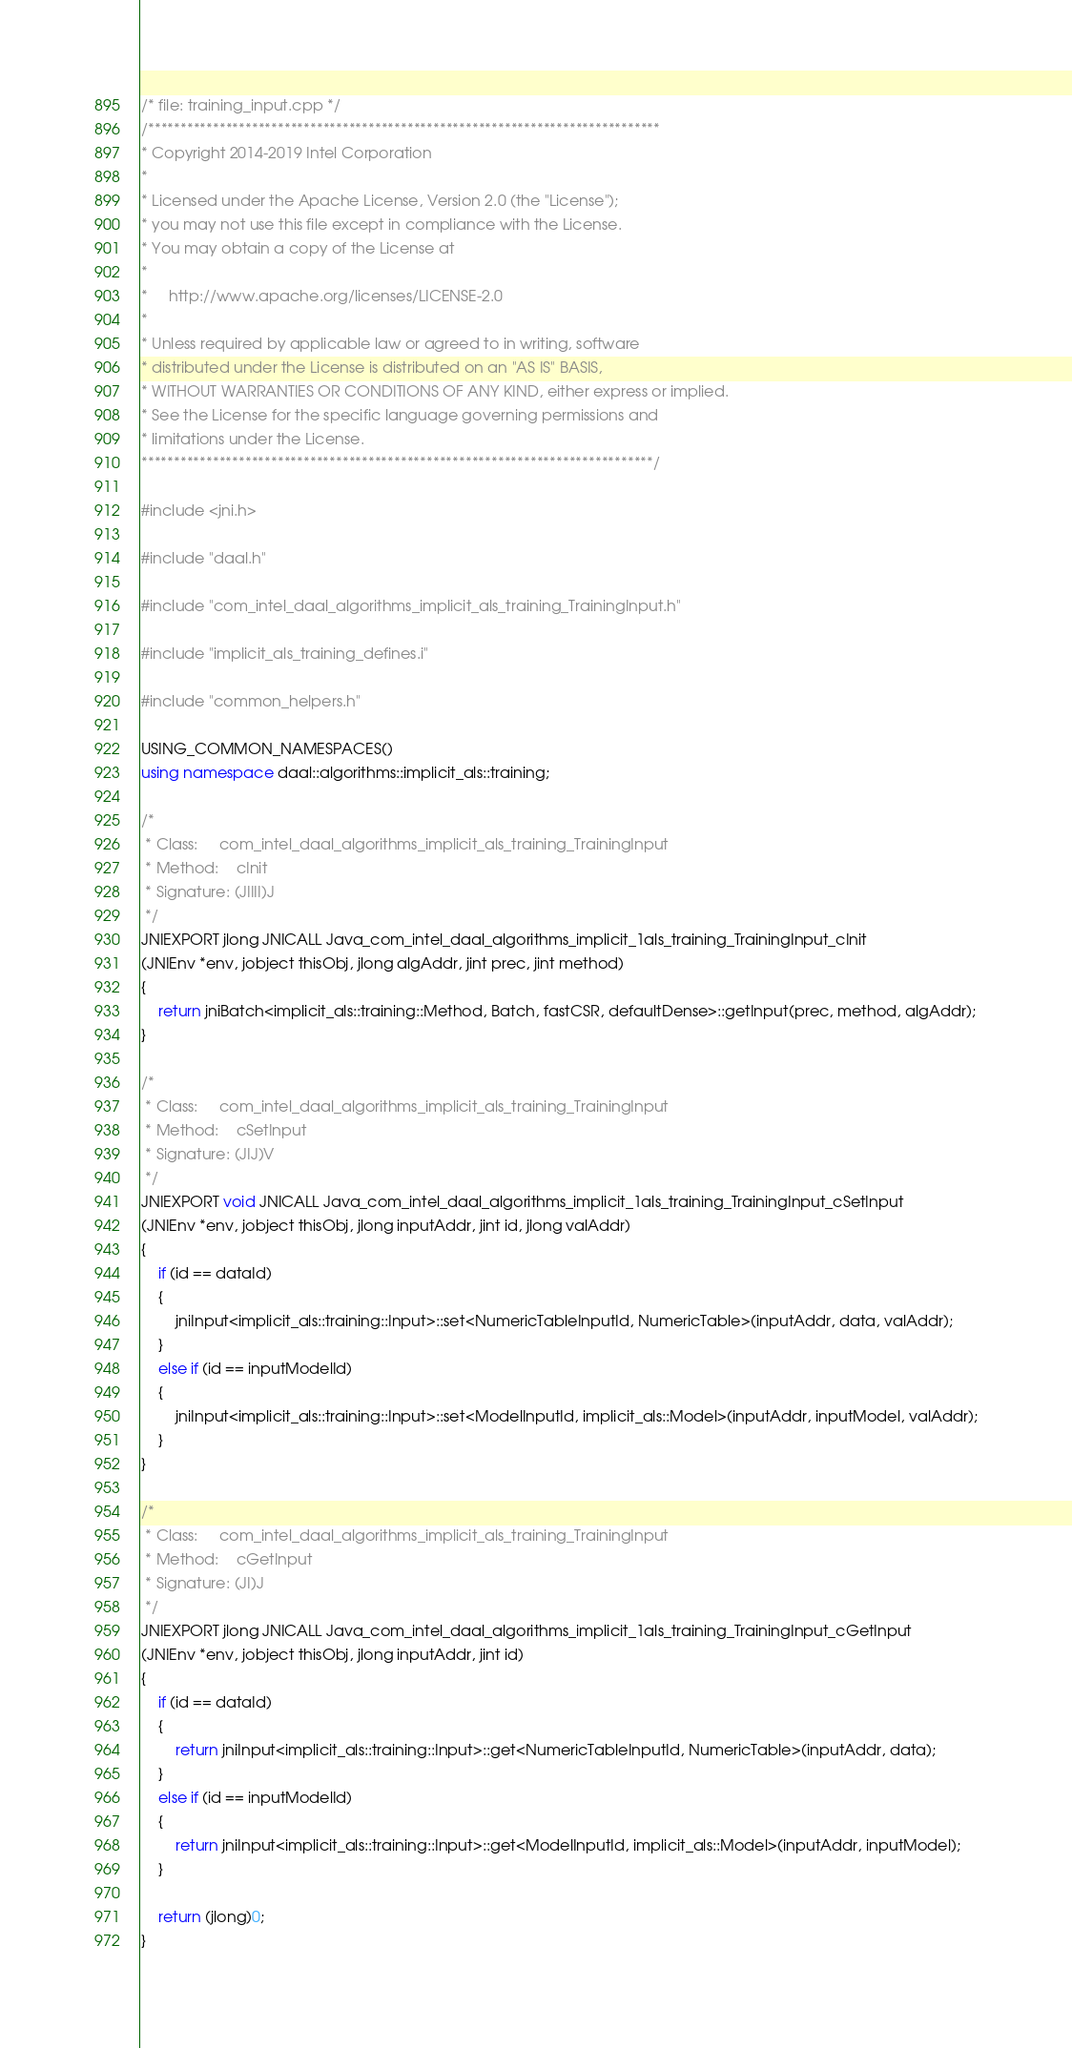<code> <loc_0><loc_0><loc_500><loc_500><_C++_>/* file: training_input.cpp */
/*******************************************************************************
* Copyright 2014-2019 Intel Corporation
*
* Licensed under the Apache License, Version 2.0 (the "License");
* you may not use this file except in compliance with the License.
* You may obtain a copy of the License at
*
*     http://www.apache.org/licenses/LICENSE-2.0
*
* Unless required by applicable law or agreed to in writing, software
* distributed under the License is distributed on an "AS IS" BASIS,
* WITHOUT WARRANTIES OR CONDITIONS OF ANY KIND, either express or implied.
* See the License for the specific language governing permissions and
* limitations under the License.
*******************************************************************************/

#include <jni.h>

#include "daal.h"

#include "com_intel_daal_algorithms_implicit_als_training_TrainingInput.h"

#include "implicit_als_training_defines.i"

#include "common_helpers.h"

USING_COMMON_NAMESPACES()
using namespace daal::algorithms::implicit_als::training;

/*
 * Class:     com_intel_daal_algorithms_implicit_als_training_TrainingInput
 * Method:    cInit
 * Signature: (JIIII)J
 */
JNIEXPORT jlong JNICALL Java_com_intel_daal_algorithms_implicit_1als_training_TrainingInput_cInit
(JNIEnv *env, jobject thisObj, jlong algAddr, jint prec, jint method)
{
    return jniBatch<implicit_als::training::Method, Batch, fastCSR, defaultDense>::getInput(prec, method, algAddr);
}

/*
 * Class:     com_intel_daal_algorithms_implicit_als_training_TrainingInput
 * Method:    cSetInput
 * Signature: (JIJ)V
 */
JNIEXPORT void JNICALL Java_com_intel_daal_algorithms_implicit_1als_training_TrainingInput_cSetInput
(JNIEnv *env, jobject thisObj, jlong inputAddr, jint id, jlong valAddr)
{
    if (id == dataId)
    {
        jniInput<implicit_als::training::Input>::set<NumericTableInputId, NumericTable>(inputAddr, data, valAddr);
    }
    else if (id == inputModelId)
    {
        jniInput<implicit_als::training::Input>::set<ModelInputId, implicit_als::Model>(inputAddr, inputModel, valAddr);
    }
}

/*
 * Class:     com_intel_daal_algorithms_implicit_als_training_TrainingInput
 * Method:    cGetInput
 * Signature: (JI)J
 */
JNIEXPORT jlong JNICALL Java_com_intel_daal_algorithms_implicit_1als_training_TrainingInput_cGetInput
(JNIEnv *env, jobject thisObj, jlong inputAddr, jint id)
{
    if (id == dataId)
    {
        return jniInput<implicit_als::training::Input>::get<NumericTableInputId, NumericTable>(inputAddr, data);
    }
    else if (id == inputModelId)
    {
        return jniInput<implicit_als::training::Input>::get<ModelInputId, implicit_als::Model>(inputAddr, inputModel);
    }

    return (jlong)0;
}
</code> 